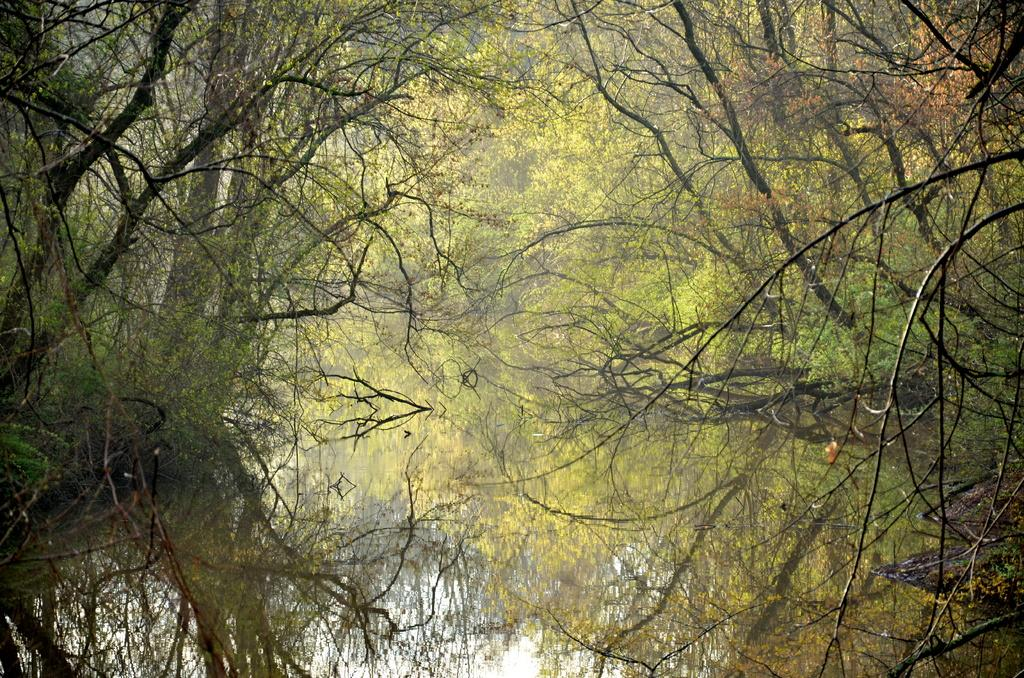What type of natural vegetation is present in the image? There is a group of trees in the image. How many dimes can be seen on the ground near the trees in the image? There are no dimes present in the image; it only features a group of trees. What type of form or structure is visible near the trees in the image? There is no specific form or structure visible near the trees in the image; it only features a group of trees. 